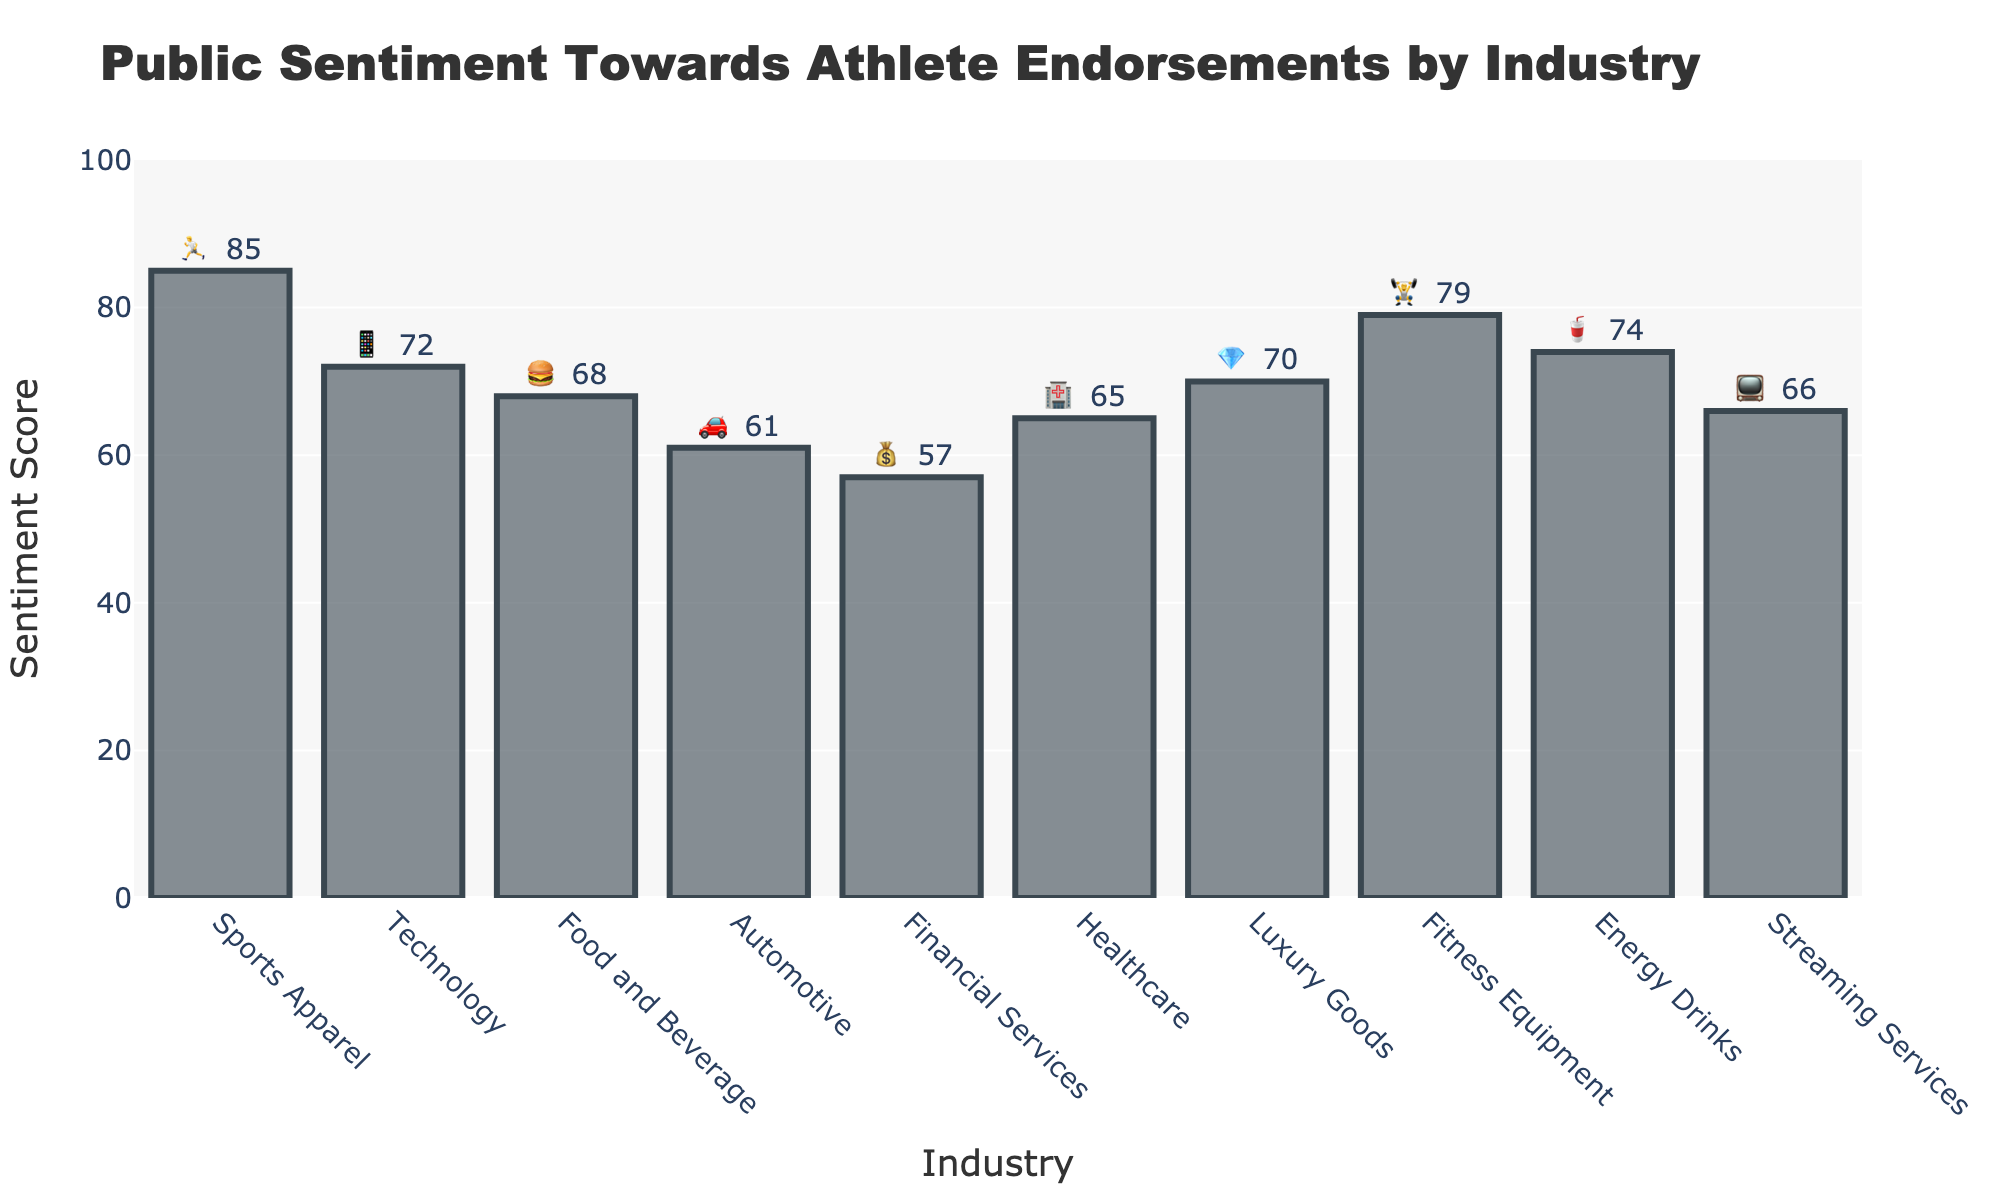What is the title of the figure? The title of the figure is displayed at the top and it reads "Public Sentiment Towards Athlete Endorsements by Industry".
Answer: Public Sentiment Towards Athlete Endorsements by Industry Which industry has the highest sentiment score and what is it? Look at the bar with the highest height on the y-axis. The industry with the highest bar is "Sports Apparel" with a sentiment score of 85.
Answer: Sports Apparel, 85 🏃 How many industries have a sentiment score above 70? Identify the bars that have a y-value greater than 70. There are four industries: Sports Apparel, Technology, Fitness Equipment, and Energy Drinks.
Answer: 4 What is the sentiment score for Energy Drinks and what emoji represents it? Locate the "Energy Drinks" bar and read its y-value and emoji. The sentiment score is 74 and the emoji is 🥤.
Answer: 74, 🥤 Which industry has the lowest sentiment score and what is it? Look at the shortest bar on the y-axis. The industry with the shortest bar is "Financial Services" with a sentiment score of 57.
Answer: Financial Services, 57 💰 What is the average sentiment score across all industries? Add all the sentiment scores and divide by the number of industries: (85 + 72 + 68 + 61 + 57 + 65 + 70 + 79 + 74 + 66) / 10 = 69.7.
Answer: 69.7 Which two industries have the closest sentiment scores? Find the pairs of industries with sentiment scores that are numerically close. "Food and Beverage" (68) and "Streaming Services" (66) have scores that are very close.
Answer: Food and Beverage and Streaming Services What is the difference in sentiment score between Luxury Goods and Healthcare? Subtract the sentiment scores of Healthcare (65) from Luxury Goods (70). 70 - 65 = 5.
Answer: 5 Which three industries have sentiment scores between 65 and 75? Find the industries within the y-value range of 65 to 75. These are: Technology (72), Luxury Goods (70), and Streaming Services (66).
Answer: Technology, Luxury Goods, Streaming Services What is the median sentiment score of all the industries? List all sentiment scores in ascending order (57, 61, 65, 66, 68, 70, 72, 74, 79, 85) and find the middle value. Since there are 10 scores, the median is the average of the 5th and 6th values: (68 + 70) / 2 = 69.
Answer: 69 